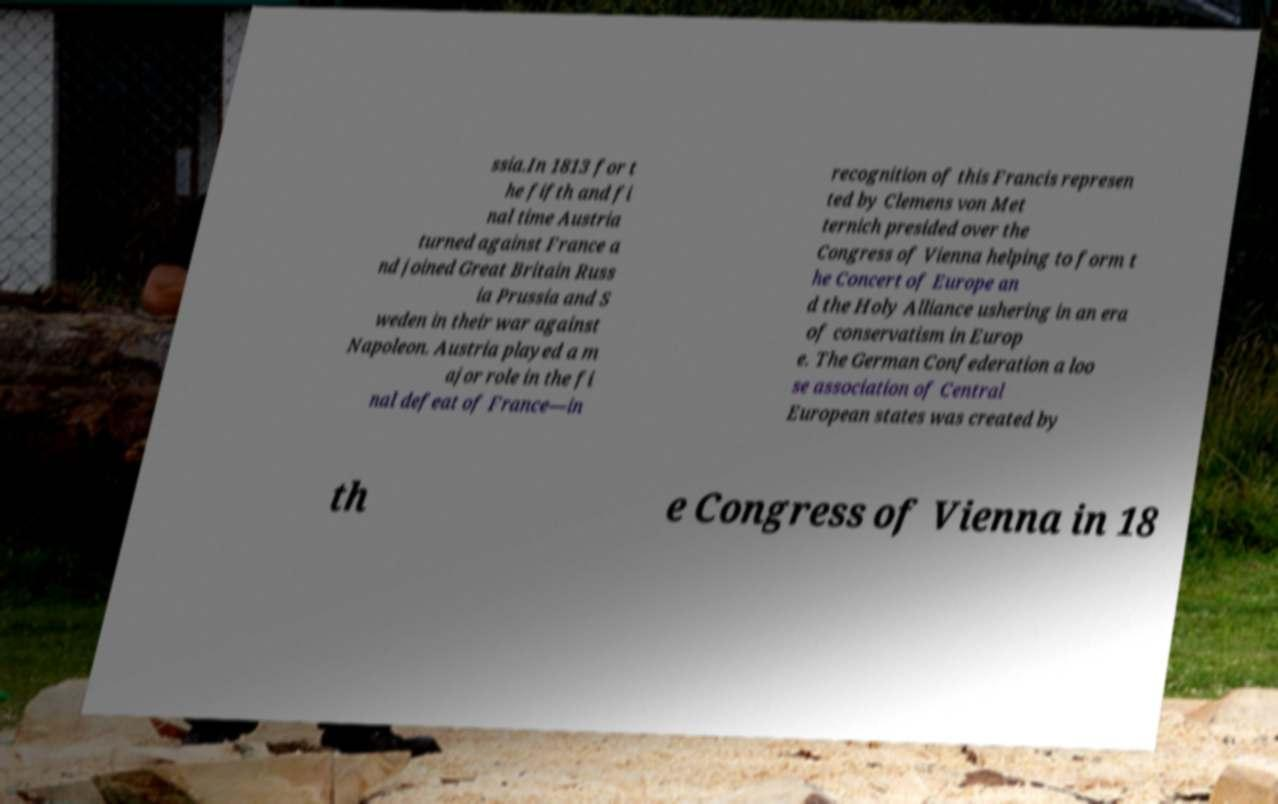Please read and relay the text visible in this image. What does it say? ssia.In 1813 for t he fifth and fi nal time Austria turned against France a nd joined Great Britain Russ ia Prussia and S weden in their war against Napoleon. Austria played a m ajor role in the fi nal defeat of France—in recognition of this Francis represen ted by Clemens von Met ternich presided over the Congress of Vienna helping to form t he Concert of Europe an d the Holy Alliance ushering in an era of conservatism in Europ e. The German Confederation a loo se association of Central European states was created by th e Congress of Vienna in 18 